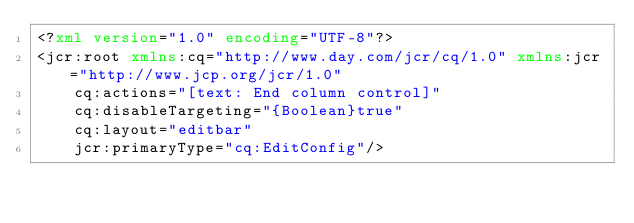<code> <loc_0><loc_0><loc_500><loc_500><_XML_><?xml version="1.0" encoding="UTF-8"?>
<jcr:root xmlns:cq="http://www.day.com/jcr/cq/1.0" xmlns:jcr="http://www.jcp.org/jcr/1.0"
    cq:actions="[text: End column control]"
    cq:disableTargeting="{Boolean}true"
    cq:layout="editbar"
    jcr:primaryType="cq:EditConfig"/>
</code> 